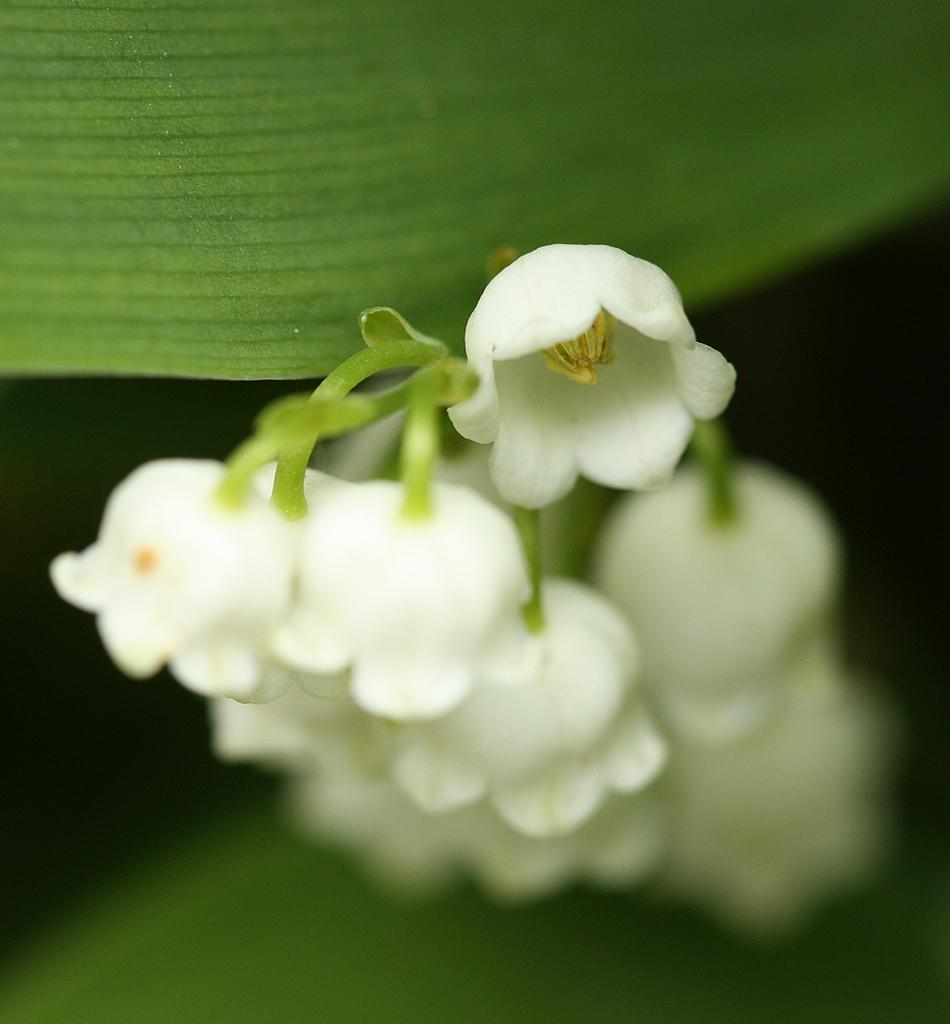What type of plant is depicted in the image? There are white flowers on a branch in the image. What else can be seen on the branch besides the flowers? There are leaves visible in the image. How would you describe the overall lighting in the image? The background of the image appears dark. What type of credit card is shown being used at the harbor in the image? There is no credit card or harbor present in the image; it features white flowers on a branch with leaves. 